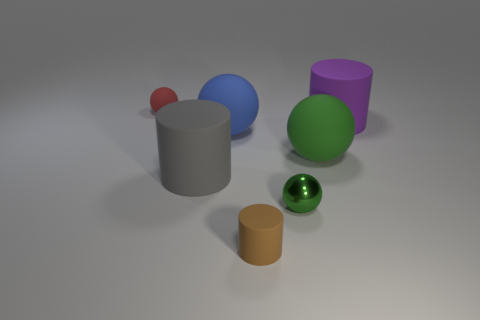Is there a small rubber ball that has the same color as the metal thing?
Give a very brief answer. No. Are the small sphere that is left of the gray object and the green thing that is in front of the gray thing made of the same material?
Make the answer very short. No. What color is the small matte cylinder?
Your answer should be very brief. Brown. What is the size of the rubber cylinder that is on the right side of the tiny sphere that is to the right of the small object that is behind the large green rubber ball?
Your answer should be very brief. Large. What number of other things are the same size as the gray matte object?
Your answer should be very brief. 3. How many red objects are the same material as the large gray cylinder?
Your answer should be compact. 1. What shape is the tiny thing that is behind the gray rubber cylinder?
Provide a succinct answer. Sphere. Do the big gray object and the small sphere to the left of the brown matte cylinder have the same material?
Your answer should be compact. Yes. Are there any big green shiny cylinders?
Keep it short and to the point. No. There is a matte ball that is to the right of the small rubber object that is in front of the large purple thing; is there a big green matte thing behind it?
Offer a very short reply. No. 